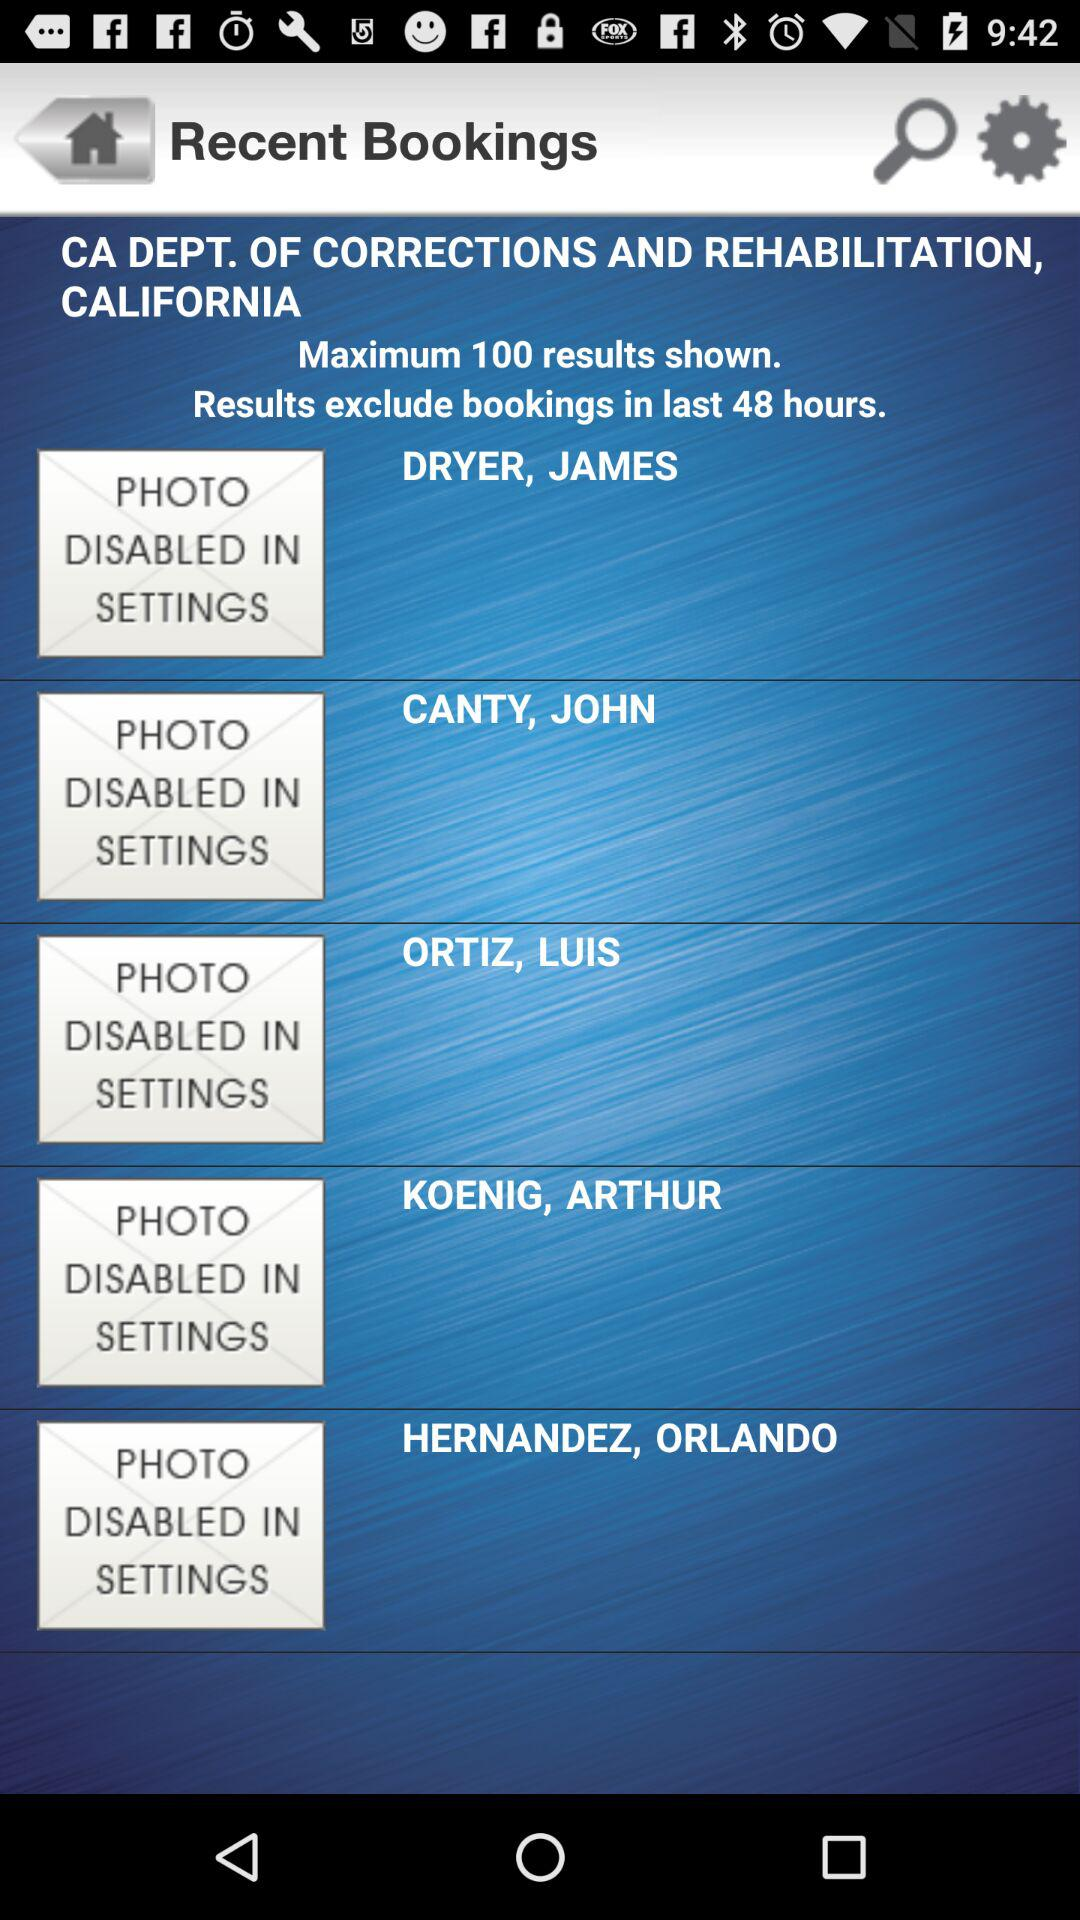What is the CA Department's city? The CA Department's city is California. 